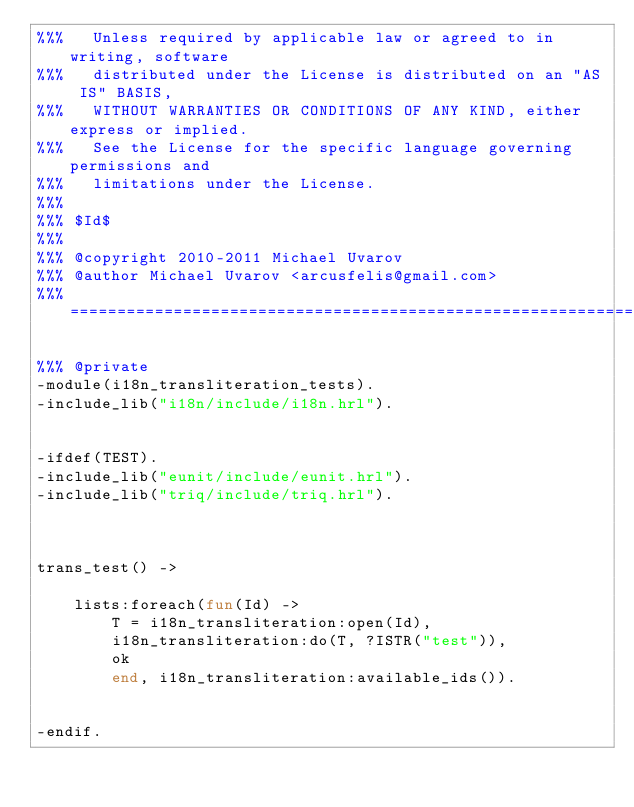Convert code to text. <code><loc_0><loc_0><loc_500><loc_500><_Erlang_>%%%   Unless required by applicable law or agreed to in writing, software
%%%   distributed under the License is distributed on an "AS IS" BASIS,
%%%   WITHOUT WARRANTIES OR CONDITIONS OF ANY KIND, either express or implied.
%%%   See the License for the specific language governing permissions and
%%%   limitations under the License.
%%%
%%% $Id$
%%%
%%% @copyright 2010-2011 Michael Uvarov
%%% @author Michael Uvarov <arcusfelis@gmail.com>
%%% =====================================================================

%%% @private
-module(i18n_transliteration_tests).
-include_lib("i18n/include/i18n.hrl").


-ifdef(TEST).
-include_lib("eunit/include/eunit.hrl").
-include_lib("triq/include/triq.hrl").

    

trans_test() ->
    
    lists:foreach(fun(Id) ->
        T = i18n_transliteration:open(Id),
        i18n_transliteration:do(T, ?ISTR("test")),
        ok
        end, i18n_transliteration:available_ids()).


-endif.
</code> 